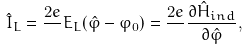Convert formula to latex. <formula><loc_0><loc_0><loc_500><loc_500>\hat { I } _ { L } = \frac { 2 e } { } E _ { L } ( \hat { \varphi } - \varphi _ { 0 } ) = \frac { 2 e } { } \frac { \partial \hat { H } _ { i n d } } { \partial \hat { \varphi } } ,</formula> 